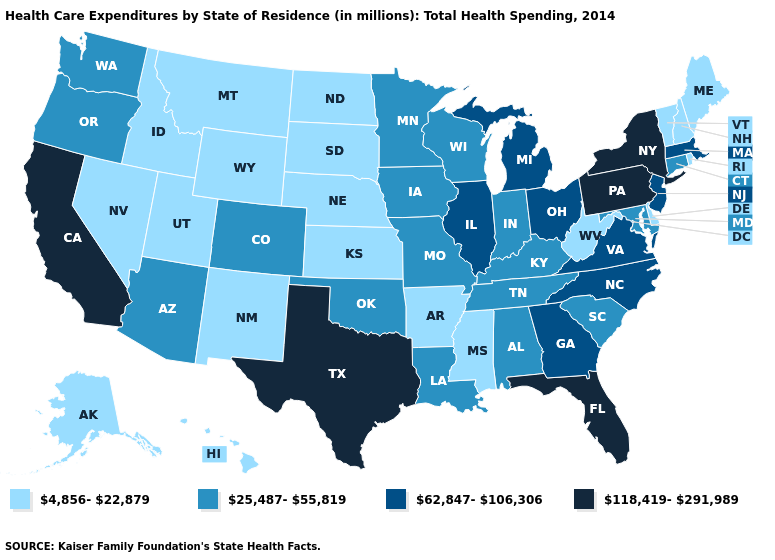What is the highest value in states that border Utah?
Answer briefly. 25,487-55,819. What is the lowest value in the West?
Be succinct. 4,856-22,879. Does Delaware have a higher value than New Jersey?
Quick response, please. No. Does Colorado have a higher value than Connecticut?
Short answer required. No. Which states have the lowest value in the West?
Quick response, please. Alaska, Hawaii, Idaho, Montana, Nevada, New Mexico, Utah, Wyoming. What is the highest value in states that border Illinois?
Short answer required. 25,487-55,819. Which states have the lowest value in the USA?
Concise answer only. Alaska, Arkansas, Delaware, Hawaii, Idaho, Kansas, Maine, Mississippi, Montana, Nebraska, Nevada, New Hampshire, New Mexico, North Dakota, Rhode Island, South Dakota, Utah, Vermont, West Virginia, Wyoming. Does Alaska have the lowest value in the West?
Be succinct. Yes. Among the states that border Tennessee , which have the highest value?
Answer briefly. Georgia, North Carolina, Virginia. Name the states that have a value in the range 118,419-291,989?
Keep it brief. California, Florida, New York, Pennsylvania, Texas. What is the value of Delaware?
Give a very brief answer. 4,856-22,879. Does New Jersey have a higher value than Texas?
Keep it brief. No. Does North Carolina have the lowest value in the USA?
Be succinct. No. What is the value of Alaska?
Keep it brief. 4,856-22,879. 